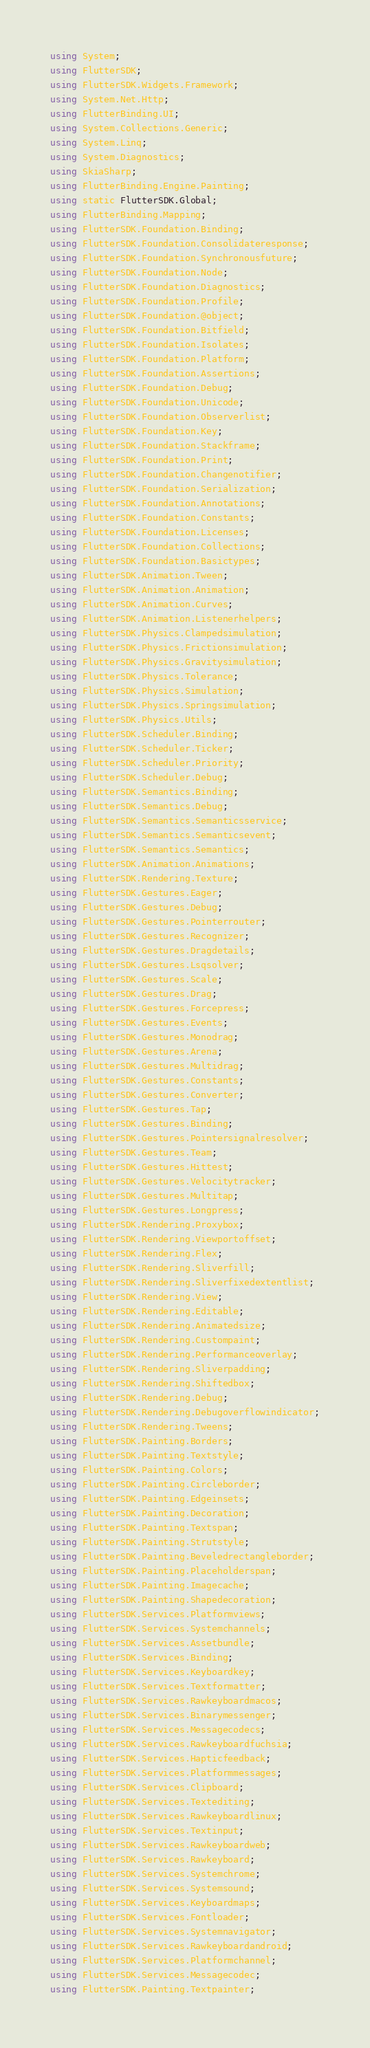<code> <loc_0><loc_0><loc_500><loc_500><_C#_>using System;
using FlutterSDK;
using FlutterSDK.Widgets.Framework;
using System.Net.Http;
using FlutterBinding.UI;
using System.Collections.Generic;
using System.Linq;
using System.Diagnostics;
using SkiaSharp;
using FlutterBinding.Engine.Painting;
using static FlutterSDK.Global;
using FlutterBinding.Mapping;
using FlutterSDK.Foundation.Binding;
using FlutterSDK.Foundation.Consolidateresponse;
using FlutterSDK.Foundation.Synchronousfuture;
using FlutterSDK.Foundation.Node;
using FlutterSDK.Foundation.Diagnostics;
using FlutterSDK.Foundation.Profile;
using FlutterSDK.Foundation.@object;
using FlutterSDK.Foundation.Bitfield;
using FlutterSDK.Foundation.Isolates;
using FlutterSDK.Foundation.Platform;
using FlutterSDK.Foundation.Assertions;
using FlutterSDK.Foundation.Debug;
using FlutterSDK.Foundation.Unicode;
using FlutterSDK.Foundation.Observerlist;
using FlutterSDK.Foundation.Key;
using FlutterSDK.Foundation.Stackframe;
using FlutterSDK.Foundation.Print;
using FlutterSDK.Foundation.Changenotifier;
using FlutterSDK.Foundation.Serialization;
using FlutterSDK.Foundation.Annotations;
using FlutterSDK.Foundation.Constants;
using FlutterSDK.Foundation.Licenses;
using FlutterSDK.Foundation.Collections;
using FlutterSDK.Foundation.Basictypes;
using FlutterSDK.Animation.Tween;
using FlutterSDK.Animation.Animation;
using FlutterSDK.Animation.Curves;
using FlutterSDK.Animation.Listenerhelpers;
using FlutterSDK.Physics.Clampedsimulation;
using FlutterSDK.Physics.Frictionsimulation;
using FlutterSDK.Physics.Gravitysimulation;
using FlutterSDK.Physics.Tolerance;
using FlutterSDK.Physics.Simulation;
using FlutterSDK.Physics.Springsimulation;
using FlutterSDK.Physics.Utils;
using FlutterSDK.Scheduler.Binding;
using FlutterSDK.Scheduler.Ticker;
using FlutterSDK.Scheduler.Priority;
using FlutterSDK.Scheduler.Debug;
using FlutterSDK.Semantics.Binding;
using FlutterSDK.Semantics.Debug;
using FlutterSDK.Semantics.Semanticsservice;
using FlutterSDK.Semantics.Semanticsevent;
using FlutterSDK.Semantics.Semantics;
using FlutterSDK.Animation.Animations;
using FlutterSDK.Rendering.Texture;
using FlutterSDK.Gestures.Eager;
using FlutterSDK.Gestures.Debug;
using FlutterSDK.Gestures.Pointerrouter;
using FlutterSDK.Gestures.Recognizer;
using FlutterSDK.Gestures.Dragdetails;
using FlutterSDK.Gestures.Lsqsolver;
using FlutterSDK.Gestures.Scale;
using FlutterSDK.Gestures.Drag;
using FlutterSDK.Gestures.Forcepress;
using FlutterSDK.Gestures.Events;
using FlutterSDK.Gestures.Monodrag;
using FlutterSDK.Gestures.Arena;
using FlutterSDK.Gestures.Multidrag;
using FlutterSDK.Gestures.Constants;
using FlutterSDK.Gestures.Converter;
using FlutterSDK.Gestures.Tap;
using FlutterSDK.Gestures.Binding;
using FlutterSDK.Gestures.Pointersignalresolver;
using FlutterSDK.Gestures.Team;
using FlutterSDK.Gestures.Hittest;
using FlutterSDK.Gestures.Velocitytracker;
using FlutterSDK.Gestures.Multitap;
using FlutterSDK.Gestures.Longpress;
using FlutterSDK.Rendering.Proxybox;
using FlutterSDK.Rendering.Viewportoffset;
using FlutterSDK.Rendering.Flex;
using FlutterSDK.Rendering.Sliverfill;
using FlutterSDK.Rendering.Sliverfixedextentlist;
using FlutterSDK.Rendering.View;
using FlutterSDK.Rendering.Editable;
using FlutterSDK.Rendering.Animatedsize;
using FlutterSDK.Rendering.Custompaint;
using FlutterSDK.Rendering.Performanceoverlay;
using FlutterSDK.Rendering.Sliverpadding;
using FlutterSDK.Rendering.Shiftedbox;
using FlutterSDK.Rendering.Debug;
using FlutterSDK.Rendering.Debugoverflowindicator;
using FlutterSDK.Rendering.Tweens;
using FlutterSDK.Painting.Borders;
using FlutterSDK.Painting.Textstyle;
using FlutterSDK.Painting.Colors;
using FlutterSDK.Painting.Circleborder;
using FlutterSDK.Painting.Edgeinsets;
using FlutterSDK.Painting.Decoration;
using FlutterSDK.Painting.Textspan;
using FlutterSDK.Painting.Strutstyle;
using FlutterSDK.Painting.Beveledrectangleborder;
using FlutterSDK.Painting.Placeholderspan;
using FlutterSDK.Painting.Imagecache;
using FlutterSDK.Painting.Shapedecoration;
using FlutterSDK.Services.Platformviews;
using FlutterSDK.Services.Systemchannels;
using FlutterSDK.Services.Assetbundle;
using FlutterSDK.Services.Binding;
using FlutterSDK.Services.Keyboardkey;
using FlutterSDK.Services.Textformatter;
using FlutterSDK.Services.Rawkeyboardmacos;
using FlutterSDK.Services.Binarymessenger;
using FlutterSDK.Services.Messagecodecs;
using FlutterSDK.Services.Rawkeyboardfuchsia;
using FlutterSDK.Services.Hapticfeedback;
using FlutterSDK.Services.Platformmessages;
using FlutterSDK.Services.Clipboard;
using FlutterSDK.Services.Textediting;
using FlutterSDK.Services.Rawkeyboardlinux;
using FlutterSDK.Services.Textinput;
using FlutterSDK.Services.Rawkeyboardweb;
using FlutterSDK.Services.Rawkeyboard;
using FlutterSDK.Services.Systemchrome;
using FlutterSDK.Services.Systemsound;
using FlutterSDK.Services.Keyboardmaps;
using FlutterSDK.Services.Fontloader;
using FlutterSDK.Services.Systemnavigator;
using FlutterSDK.Services.Rawkeyboardandroid;
using FlutterSDK.Services.Platformchannel;
using FlutterSDK.Services.Messagecodec;
using FlutterSDK.Painting.Textpainter;</code> 